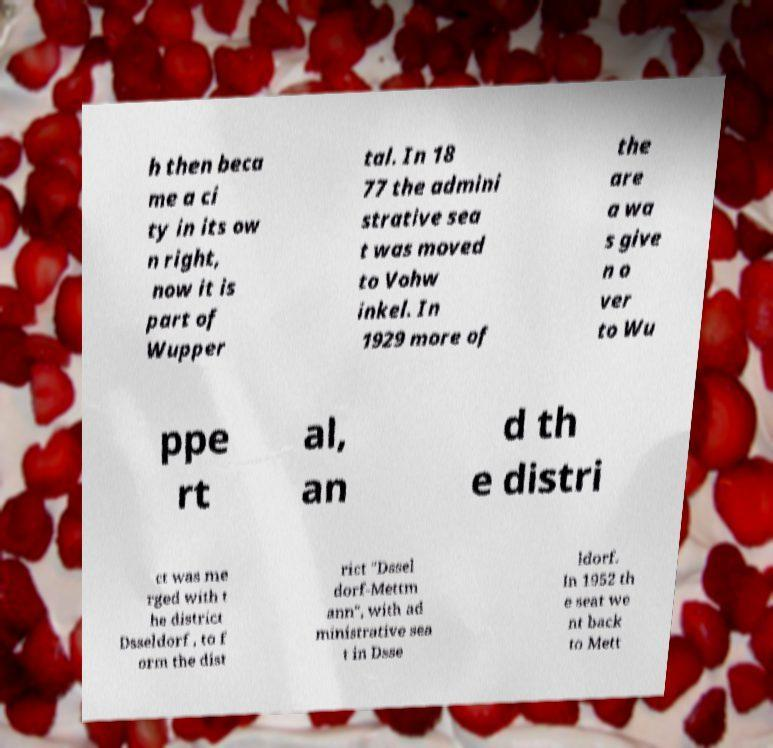Can you accurately transcribe the text from the provided image for me? h then beca me a ci ty in its ow n right, now it is part of Wupper tal. In 18 77 the admini strative sea t was moved to Vohw inkel. In 1929 more of the are a wa s give n o ver to Wu ppe rt al, an d th e distri ct was me rged with t he district Dsseldorf , to f orm the dist rict "Dssel dorf-Mettm ann", with ad ministrative sea t in Dsse ldorf. In 1952 th e seat we nt back to Mett 